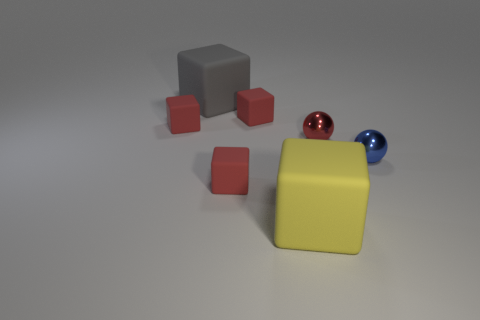Subtract all small red cubes. How many cubes are left? 2 Add 1 tiny metal spheres. How many objects exist? 8 Subtract all cubes. How many objects are left? 2 Add 6 large gray objects. How many large gray objects are left? 7 Add 7 big rubber things. How many big rubber things exist? 9 Subtract all blue spheres. How many spheres are left? 1 Subtract 0 red cylinders. How many objects are left? 7 Subtract 2 balls. How many balls are left? 0 Subtract all red cubes. Subtract all cyan cylinders. How many cubes are left? 2 Subtract all gray spheres. How many brown blocks are left? 0 